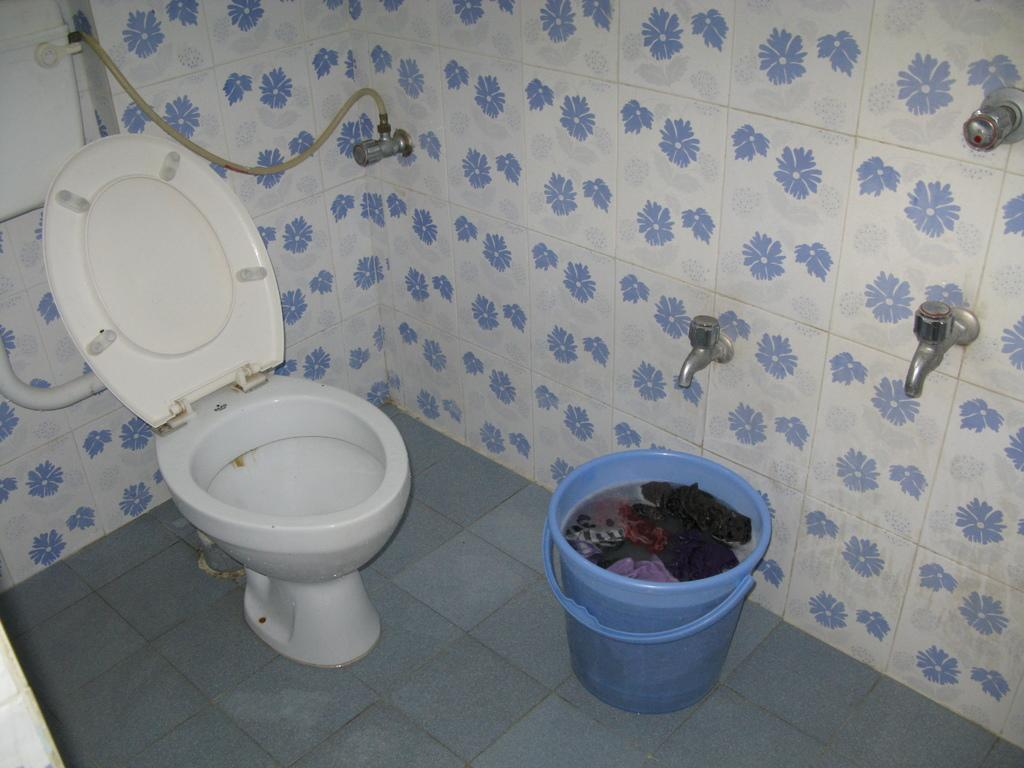What is the main object in the image? There is a toilet seat in the image. What else can be seen in the image? There is a bucket in the image. What is inside the bucket? The bucket contains water and clothes. What feature is present on the wall in the image? There are taps on the wall in the image. What type of van is parked outside the hospital in the image? There is no van or hospital present in the image; it only features a toilet seat, a bucket, and taps on the wall. 